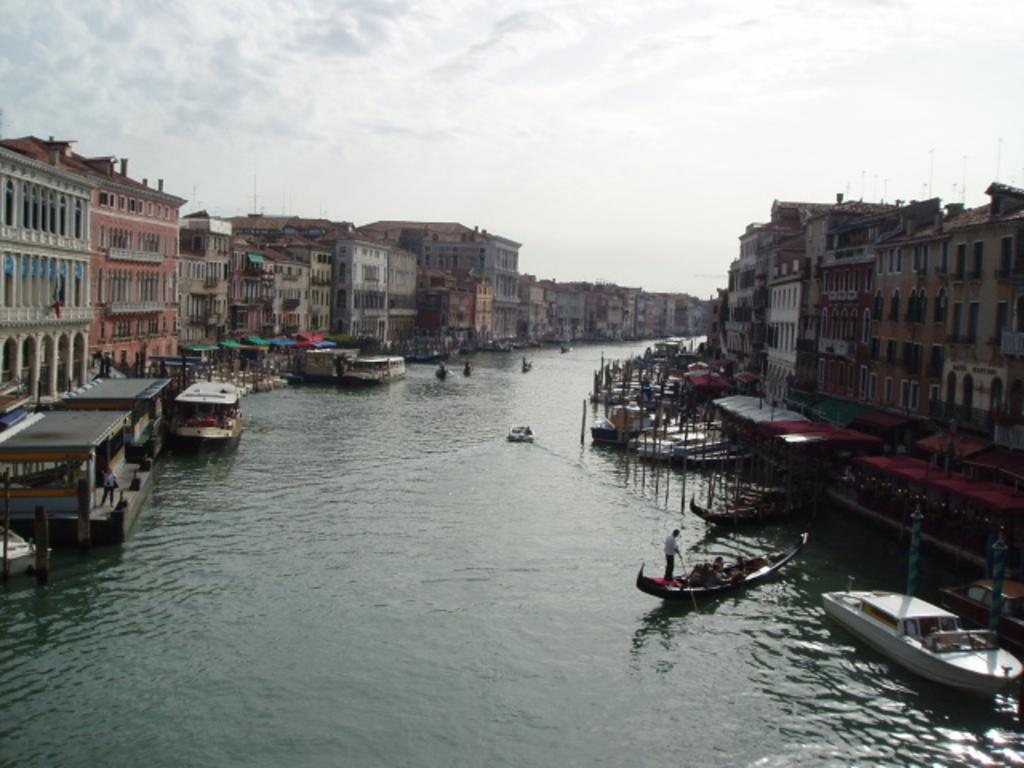What is the main subject in the center of the image? There are boats in the water in the center of the image. What can be seen on the sides of the image? There are buildings on both the right and left sides of the image. What is visible in the background of the image? The sky is visible in the background of the image. Can you tell me how many doctors are present in the image? There are no doctors present in the image; it features boats in the water and buildings on both sides. What type of division is visible in the image? There is no division present in the image; it shows boats, buildings, and the sky. 